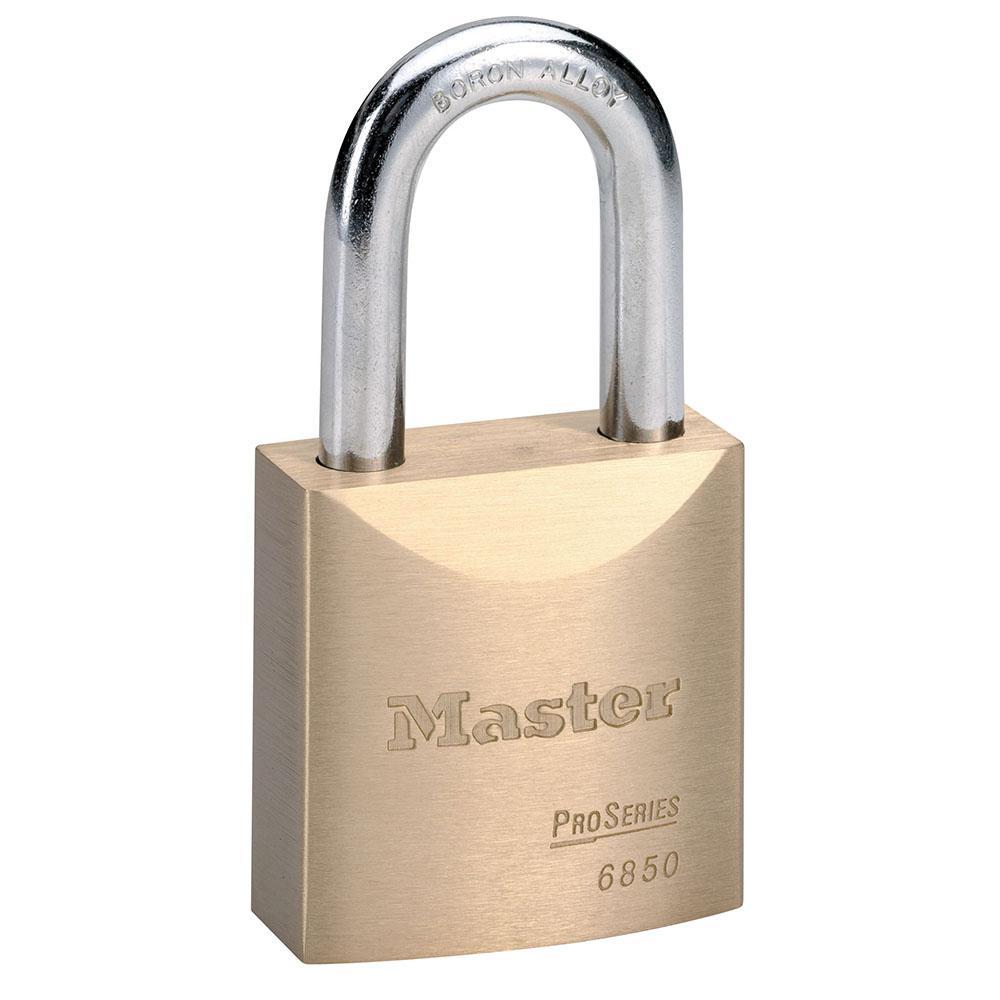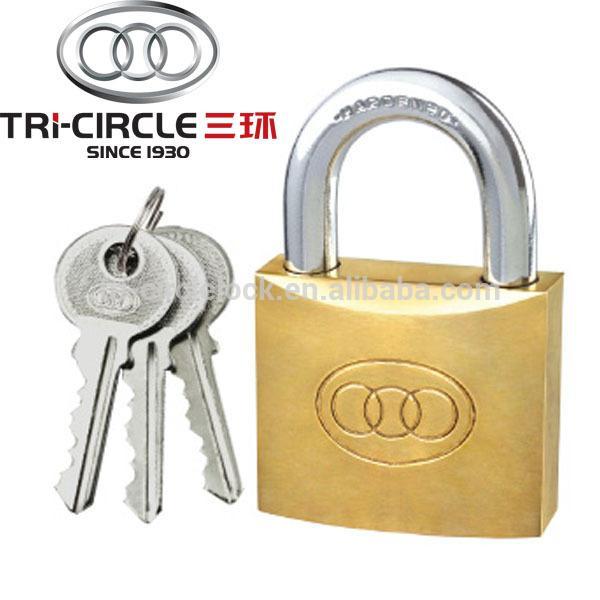The first image is the image on the left, the second image is the image on the right. Considering the images on both sides, is "There are at least 3 keys on keyrings." valid? Answer yes or no. Yes. The first image is the image on the left, the second image is the image on the right. For the images shown, is this caption "There is only one key." true? Answer yes or no. No. 